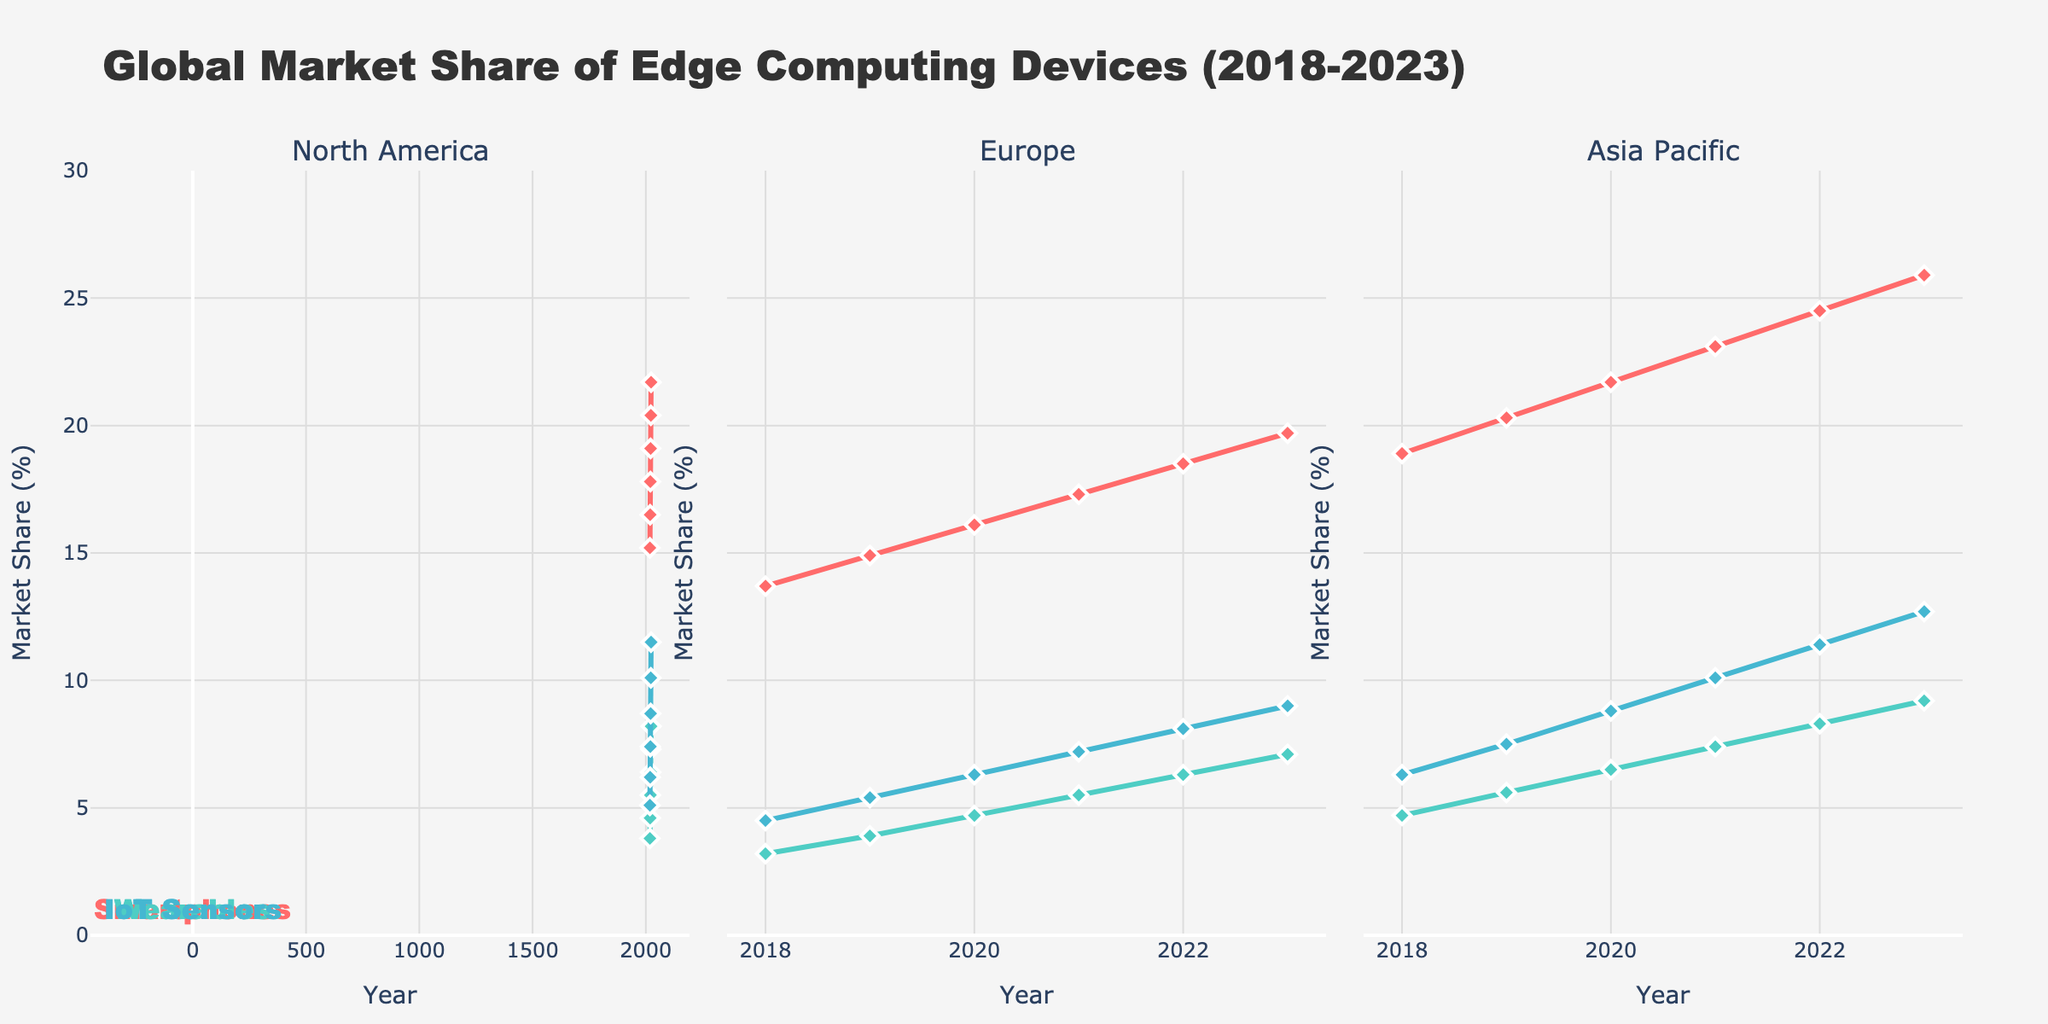Which region had the highest market share for IoT Sensors in 2023? To find this, we look at the 'IoT Sensors' segment in 2023 across the regions. The values are: North America: 11.5, Europe: 9.0, Asia Pacific: 12.7. Comparing these, Asia Pacific has the highest value.
Answer: Asia Pacific How did the market share of North America Wearables change from 2018 to 2023? Check the values for North America Wearables in 2018 and 2023. The values are 3.8% in 2018 and 8.2% in 2023. The change is 8.2 - 3.8 = 4.4%.
Answer: Increased by 4.4% Among the three device types in Europe, which had the least growth in market share from 2018 to 2023? Calculate the growth for each device type in Europe from 2018 to 2023: Smartphones: 19.7 - 13.7 = 6.0%, Wearables: 7.1 - 3.2 = 3.9%, IoT Sensors: 9.0 - 4.5 = 4.5%. The Wearables had the least growth.
Answer: Wearables What is the average market share of Asia Pacific Smartphones from 2018 to 2023? List all values for Asia Pacific Smartphones from 2018 to 2023: 18.9, 20.3, 21.7, 23.1, 24.5, 25.9. Sum these values: 18.9 + 20.3 + 21.7 + 23.1 + 24.5 + 25.9 = 134.4. Divide by 6 (number of years): 134.4 / 6 = 22.4%.
Answer: 22.4% Which region's Wearables segment showed the most consistent increase over the years 2018 to 2023? Evaluate the trend for Wearables in each region. North America has increases each year: 3.8, 4.6, 5.5, 6.4, 7.3, 8.2. Europe and Asia Pacific have similar increasing trends, but North America's increases appear most consistent.
Answer: North America In 2021, which device type in Asia Pacific had the highest market share? Look at the values for Asia Pacific in 2021. Smartphones: 23.1%, Wearables: 7.4%, IoT Sensors: 10.1%. The highest value among these is Smartphones.
Answer: Smartphones Between 2019 and 2022, which region's Smartphones segment saw the greatest increase in market share? Calculate the increase for each region's Smartphones between 2019 and 2022. North America: 20.4 - 16.5 = 3.9%, Europe: 18.5 - 14.9 = 3.6%, Asia Pacific: 24.5 - 20.3 = 4.2%. Asia Pacific had the greatest increase.
Answer: Asia Pacific Compare the market share of IoT Sensors in North America vs Europe in 2023. Which is greater and by how much? Compare the values for North America and Europe in 2023 for IoT Sensors. North America: 11.5%, Europe: 9.0%. Difference: 11.5 - 9.0 = 2.5%. North America has the greater market share by 2.5%.
Answer: North America by 2.5% Across all regions, what was the combined market share for Smartphones in 2020? Sum the values for Smartphones in 2020 across all regions: North America: 17.8, Europe: 16.1, Asia Pacific: 21.7. Combined market share: 17.8 + 16.1 + 21.7 = 55.6%.
Answer: 55.6% Which region had the slowest overall increase in market share for Wearables from 2018 to 2023? Calculate the increase in market share for Wearables in each region: North America: 8.2 - 3.8 = 4.4%, Europe: 7.1 - 3.2 = 3.9%, Asia Pacific: 9.2 - 4.7 = 4.5%. Europe had the slowest increase.
Answer: Europe 